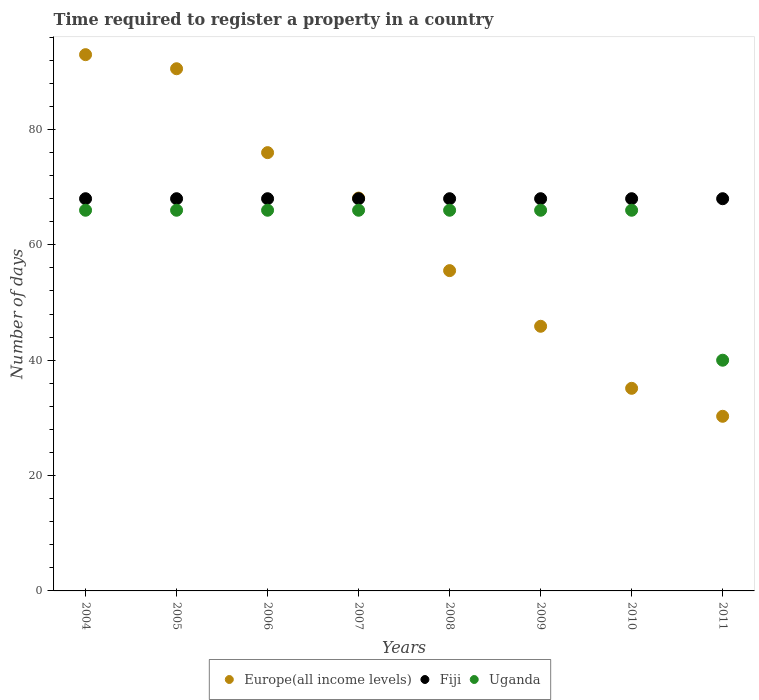Is the number of dotlines equal to the number of legend labels?
Give a very brief answer. Yes. What is the number of days required to register a property in Fiji in 2007?
Your response must be concise. 68. Across all years, what is the maximum number of days required to register a property in Europe(all income levels)?
Give a very brief answer. 92.98. Across all years, what is the minimum number of days required to register a property in Europe(all income levels)?
Your response must be concise. 30.28. In which year was the number of days required to register a property in Uganda maximum?
Your answer should be compact. 2004. In which year was the number of days required to register a property in Fiji minimum?
Your response must be concise. 2004. What is the total number of days required to register a property in Fiji in the graph?
Give a very brief answer. 544. What is the difference between the number of days required to register a property in Fiji in 2010 and the number of days required to register a property in Uganda in 2007?
Your response must be concise. 2. What is the average number of days required to register a property in Europe(all income levels) per year?
Your answer should be compact. 61.8. In the year 2010, what is the difference between the number of days required to register a property in Europe(all income levels) and number of days required to register a property in Fiji?
Your answer should be very brief. -32.87. In how many years, is the number of days required to register a property in Fiji greater than 44 days?
Offer a very short reply. 8. Is the difference between the number of days required to register a property in Europe(all income levels) in 2006 and 2010 greater than the difference between the number of days required to register a property in Fiji in 2006 and 2010?
Keep it short and to the point. Yes. What is the difference between the highest and the lowest number of days required to register a property in Uganda?
Offer a terse response. 26. Is the sum of the number of days required to register a property in Europe(all income levels) in 2006 and 2008 greater than the maximum number of days required to register a property in Fiji across all years?
Offer a very short reply. Yes. Is the number of days required to register a property in Uganda strictly less than the number of days required to register a property in Fiji over the years?
Make the answer very short. Yes. What is the difference between two consecutive major ticks on the Y-axis?
Provide a succinct answer. 20. Are the values on the major ticks of Y-axis written in scientific E-notation?
Offer a terse response. No. Does the graph contain any zero values?
Your response must be concise. No. Does the graph contain grids?
Ensure brevity in your answer.  No. Where does the legend appear in the graph?
Ensure brevity in your answer.  Bottom center. How are the legend labels stacked?
Your response must be concise. Horizontal. What is the title of the graph?
Your answer should be very brief. Time required to register a property in a country. What is the label or title of the Y-axis?
Ensure brevity in your answer.  Number of days. What is the Number of days in Europe(all income levels) in 2004?
Your answer should be compact. 92.98. What is the Number of days in Fiji in 2004?
Keep it short and to the point. 68. What is the Number of days of Uganda in 2004?
Provide a short and direct response. 66. What is the Number of days of Europe(all income levels) in 2005?
Offer a terse response. 90.53. What is the Number of days of Fiji in 2005?
Your response must be concise. 68. What is the Number of days of Uganda in 2005?
Offer a terse response. 66. What is the Number of days of Europe(all income levels) in 2006?
Your response must be concise. 75.99. What is the Number of days of Fiji in 2006?
Keep it short and to the point. 68. What is the Number of days in Europe(all income levels) in 2007?
Make the answer very short. 68.11. What is the Number of days of Uganda in 2007?
Your response must be concise. 66. What is the Number of days of Europe(all income levels) in 2008?
Provide a short and direct response. 55.53. What is the Number of days of Fiji in 2008?
Provide a succinct answer. 68. What is the Number of days in Uganda in 2008?
Provide a short and direct response. 66. What is the Number of days in Europe(all income levels) in 2009?
Ensure brevity in your answer.  45.88. What is the Number of days in Europe(all income levels) in 2010?
Give a very brief answer. 35.13. What is the Number of days in Europe(all income levels) in 2011?
Your response must be concise. 30.28. Across all years, what is the maximum Number of days of Europe(all income levels)?
Ensure brevity in your answer.  92.98. Across all years, what is the maximum Number of days of Fiji?
Give a very brief answer. 68. Across all years, what is the minimum Number of days in Europe(all income levels)?
Offer a terse response. 30.28. Across all years, what is the minimum Number of days in Uganda?
Your response must be concise. 40. What is the total Number of days of Europe(all income levels) in the graph?
Make the answer very short. 494.43. What is the total Number of days in Fiji in the graph?
Offer a terse response. 544. What is the total Number of days in Uganda in the graph?
Your response must be concise. 502. What is the difference between the Number of days of Europe(all income levels) in 2004 and that in 2005?
Your answer should be compact. 2.44. What is the difference between the Number of days of Europe(all income levels) in 2004 and that in 2006?
Provide a short and direct response. 16.99. What is the difference between the Number of days in Fiji in 2004 and that in 2006?
Keep it short and to the point. 0. What is the difference between the Number of days in Uganda in 2004 and that in 2006?
Your answer should be compact. 0. What is the difference between the Number of days of Europe(all income levels) in 2004 and that in 2007?
Ensure brevity in your answer.  24.87. What is the difference between the Number of days in Europe(all income levels) in 2004 and that in 2008?
Your answer should be very brief. 37.44. What is the difference between the Number of days in Fiji in 2004 and that in 2008?
Give a very brief answer. 0. What is the difference between the Number of days in Uganda in 2004 and that in 2008?
Offer a terse response. 0. What is the difference between the Number of days in Europe(all income levels) in 2004 and that in 2009?
Your response must be concise. 47.09. What is the difference between the Number of days of Uganda in 2004 and that in 2009?
Ensure brevity in your answer.  0. What is the difference between the Number of days of Europe(all income levels) in 2004 and that in 2010?
Offer a terse response. 57.85. What is the difference between the Number of days of Fiji in 2004 and that in 2010?
Your answer should be very brief. 0. What is the difference between the Number of days in Europe(all income levels) in 2004 and that in 2011?
Your response must be concise. 62.7. What is the difference between the Number of days of Fiji in 2004 and that in 2011?
Give a very brief answer. 0. What is the difference between the Number of days of Uganda in 2004 and that in 2011?
Give a very brief answer. 26. What is the difference between the Number of days of Europe(all income levels) in 2005 and that in 2006?
Make the answer very short. 14.55. What is the difference between the Number of days in Uganda in 2005 and that in 2006?
Provide a short and direct response. 0. What is the difference between the Number of days in Europe(all income levels) in 2005 and that in 2007?
Keep it short and to the point. 22.42. What is the difference between the Number of days of Europe(all income levels) in 2005 and that in 2008?
Provide a succinct answer. 35. What is the difference between the Number of days in Fiji in 2005 and that in 2008?
Your answer should be compact. 0. What is the difference between the Number of days of Europe(all income levels) in 2005 and that in 2009?
Keep it short and to the point. 44.65. What is the difference between the Number of days in Fiji in 2005 and that in 2009?
Keep it short and to the point. 0. What is the difference between the Number of days in Europe(all income levels) in 2005 and that in 2010?
Make the answer very short. 55.41. What is the difference between the Number of days of Fiji in 2005 and that in 2010?
Give a very brief answer. 0. What is the difference between the Number of days of Europe(all income levels) in 2005 and that in 2011?
Your answer should be very brief. 60.26. What is the difference between the Number of days in Europe(all income levels) in 2006 and that in 2007?
Provide a succinct answer. 7.88. What is the difference between the Number of days of Fiji in 2006 and that in 2007?
Give a very brief answer. 0. What is the difference between the Number of days in Europe(all income levels) in 2006 and that in 2008?
Give a very brief answer. 20.46. What is the difference between the Number of days of Uganda in 2006 and that in 2008?
Keep it short and to the point. 0. What is the difference between the Number of days in Europe(all income levels) in 2006 and that in 2009?
Make the answer very short. 30.11. What is the difference between the Number of days in Europe(all income levels) in 2006 and that in 2010?
Keep it short and to the point. 40.86. What is the difference between the Number of days in Europe(all income levels) in 2006 and that in 2011?
Provide a succinct answer. 45.71. What is the difference between the Number of days in Europe(all income levels) in 2007 and that in 2008?
Make the answer very short. 12.58. What is the difference between the Number of days of Fiji in 2007 and that in 2008?
Provide a short and direct response. 0. What is the difference between the Number of days in Europe(all income levels) in 2007 and that in 2009?
Your response must be concise. 22.23. What is the difference between the Number of days in Fiji in 2007 and that in 2009?
Ensure brevity in your answer.  0. What is the difference between the Number of days in Uganda in 2007 and that in 2009?
Give a very brief answer. 0. What is the difference between the Number of days of Europe(all income levels) in 2007 and that in 2010?
Provide a short and direct response. 32.98. What is the difference between the Number of days of Uganda in 2007 and that in 2010?
Keep it short and to the point. 0. What is the difference between the Number of days of Europe(all income levels) in 2007 and that in 2011?
Ensure brevity in your answer.  37.83. What is the difference between the Number of days in Uganda in 2007 and that in 2011?
Give a very brief answer. 26. What is the difference between the Number of days of Europe(all income levels) in 2008 and that in 2009?
Provide a short and direct response. 9.65. What is the difference between the Number of days in Fiji in 2008 and that in 2009?
Provide a short and direct response. 0. What is the difference between the Number of days in Europe(all income levels) in 2008 and that in 2010?
Your response must be concise. 20.4. What is the difference between the Number of days of Europe(all income levels) in 2008 and that in 2011?
Make the answer very short. 25.26. What is the difference between the Number of days in Uganda in 2008 and that in 2011?
Provide a succinct answer. 26. What is the difference between the Number of days in Europe(all income levels) in 2009 and that in 2010?
Offer a very short reply. 10.76. What is the difference between the Number of days of Fiji in 2009 and that in 2010?
Keep it short and to the point. 0. What is the difference between the Number of days of Uganda in 2009 and that in 2010?
Make the answer very short. 0. What is the difference between the Number of days in Europe(all income levels) in 2009 and that in 2011?
Provide a succinct answer. 15.61. What is the difference between the Number of days of Europe(all income levels) in 2010 and that in 2011?
Your answer should be compact. 4.85. What is the difference between the Number of days of Europe(all income levels) in 2004 and the Number of days of Fiji in 2005?
Provide a succinct answer. 24.98. What is the difference between the Number of days of Europe(all income levels) in 2004 and the Number of days of Uganda in 2005?
Provide a short and direct response. 26.98. What is the difference between the Number of days of Europe(all income levels) in 2004 and the Number of days of Fiji in 2006?
Offer a terse response. 24.98. What is the difference between the Number of days of Europe(all income levels) in 2004 and the Number of days of Uganda in 2006?
Your answer should be compact. 26.98. What is the difference between the Number of days of Europe(all income levels) in 2004 and the Number of days of Fiji in 2007?
Your response must be concise. 24.98. What is the difference between the Number of days of Europe(all income levels) in 2004 and the Number of days of Uganda in 2007?
Your response must be concise. 26.98. What is the difference between the Number of days in Fiji in 2004 and the Number of days in Uganda in 2007?
Give a very brief answer. 2. What is the difference between the Number of days in Europe(all income levels) in 2004 and the Number of days in Fiji in 2008?
Provide a short and direct response. 24.98. What is the difference between the Number of days in Europe(all income levels) in 2004 and the Number of days in Uganda in 2008?
Ensure brevity in your answer.  26.98. What is the difference between the Number of days of Europe(all income levels) in 2004 and the Number of days of Fiji in 2009?
Offer a terse response. 24.98. What is the difference between the Number of days in Europe(all income levels) in 2004 and the Number of days in Uganda in 2009?
Provide a succinct answer. 26.98. What is the difference between the Number of days in Europe(all income levels) in 2004 and the Number of days in Fiji in 2010?
Ensure brevity in your answer.  24.98. What is the difference between the Number of days of Europe(all income levels) in 2004 and the Number of days of Uganda in 2010?
Provide a succinct answer. 26.98. What is the difference between the Number of days in Europe(all income levels) in 2004 and the Number of days in Fiji in 2011?
Your answer should be very brief. 24.98. What is the difference between the Number of days of Europe(all income levels) in 2004 and the Number of days of Uganda in 2011?
Offer a terse response. 52.98. What is the difference between the Number of days in Fiji in 2004 and the Number of days in Uganda in 2011?
Your answer should be very brief. 28. What is the difference between the Number of days in Europe(all income levels) in 2005 and the Number of days in Fiji in 2006?
Your response must be concise. 22.53. What is the difference between the Number of days in Europe(all income levels) in 2005 and the Number of days in Uganda in 2006?
Offer a terse response. 24.53. What is the difference between the Number of days in Europe(all income levels) in 2005 and the Number of days in Fiji in 2007?
Your answer should be compact. 22.53. What is the difference between the Number of days in Europe(all income levels) in 2005 and the Number of days in Uganda in 2007?
Give a very brief answer. 24.53. What is the difference between the Number of days in Europe(all income levels) in 2005 and the Number of days in Fiji in 2008?
Your response must be concise. 22.53. What is the difference between the Number of days in Europe(all income levels) in 2005 and the Number of days in Uganda in 2008?
Offer a very short reply. 24.53. What is the difference between the Number of days of Europe(all income levels) in 2005 and the Number of days of Fiji in 2009?
Your answer should be compact. 22.53. What is the difference between the Number of days of Europe(all income levels) in 2005 and the Number of days of Uganda in 2009?
Provide a succinct answer. 24.53. What is the difference between the Number of days in Fiji in 2005 and the Number of days in Uganda in 2009?
Ensure brevity in your answer.  2. What is the difference between the Number of days in Europe(all income levels) in 2005 and the Number of days in Fiji in 2010?
Keep it short and to the point. 22.53. What is the difference between the Number of days of Europe(all income levels) in 2005 and the Number of days of Uganda in 2010?
Provide a succinct answer. 24.53. What is the difference between the Number of days in Fiji in 2005 and the Number of days in Uganda in 2010?
Keep it short and to the point. 2. What is the difference between the Number of days of Europe(all income levels) in 2005 and the Number of days of Fiji in 2011?
Your answer should be compact. 22.53. What is the difference between the Number of days of Europe(all income levels) in 2005 and the Number of days of Uganda in 2011?
Your response must be concise. 50.53. What is the difference between the Number of days of Fiji in 2005 and the Number of days of Uganda in 2011?
Ensure brevity in your answer.  28. What is the difference between the Number of days of Europe(all income levels) in 2006 and the Number of days of Fiji in 2007?
Your answer should be very brief. 7.99. What is the difference between the Number of days of Europe(all income levels) in 2006 and the Number of days of Uganda in 2007?
Keep it short and to the point. 9.99. What is the difference between the Number of days of Europe(all income levels) in 2006 and the Number of days of Fiji in 2008?
Your answer should be very brief. 7.99. What is the difference between the Number of days of Europe(all income levels) in 2006 and the Number of days of Uganda in 2008?
Give a very brief answer. 9.99. What is the difference between the Number of days of Europe(all income levels) in 2006 and the Number of days of Fiji in 2009?
Offer a very short reply. 7.99. What is the difference between the Number of days of Europe(all income levels) in 2006 and the Number of days of Uganda in 2009?
Give a very brief answer. 9.99. What is the difference between the Number of days of Fiji in 2006 and the Number of days of Uganda in 2009?
Your answer should be very brief. 2. What is the difference between the Number of days of Europe(all income levels) in 2006 and the Number of days of Fiji in 2010?
Provide a short and direct response. 7.99. What is the difference between the Number of days of Europe(all income levels) in 2006 and the Number of days of Uganda in 2010?
Your answer should be very brief. 9.99. What is the difference between the Number of days of Europe(all income levels) in 2006 and the Number of days of Fiji in 2011?
Your answer should be very brief. 7.99. What is the difference between the Number of days of Europe(all income levels) in 2006 and the Number of days of Uganda in 2011?
Keep it short and to the point. 35.99. What is the difference between the Number of days in Europe(all income levels) in 2007 and the Number of days in Uganda in 2008?
Keep it short and to the point. 2.11. What is the difference between the Number of days in Fiji in 2007 and the Number of days in Uganda in 2008?
Your answer should be compact. 2. What is the difference between the Number of days in Europe(all income levels) in 2007 and the Number of days in Fiji in 2009?
Your response must be concise. 0.11. What is the difference between the Number of days of Europe(all income levels) in 2007 and the Number of days of Uganda in 2009?
Offer a terse response. 2.11. What is the difference between the Number of days of Europe(all income levels) in 2007 and the Number of days of Fiji in 2010?
Ensure brevity in your answer.  0.11. What is the difference between the Number of days in Europe(all income levels) in 2007 and the Number of days in Uganda in 2010?
Provide a short and direct response. 2.11. What is the difference between the Number of days of Europe(all income levels) in 2007 and the Number of days of Fiji in 2011?
Your answer should be compact. 0.11. What is the difference between the Number of days in Europe(all income levels) in 2007 and the Number of days in Uganda in 2011?
Your answer should be very brief. 28.11. What is the difference between the Number of days of Fiji in 2007 and the Number of days of Uganda in 2011?
Your response must be concise. 28. What is the difference between the Number of days in Europe(all income levels) in 2008 and the Number of days in Fiji in 2009?
Provide a succinct answer. -12.47. What is the difference between the Number of days in Europe(all income levels) in 2008 and the Number of days in Uganda in 2009?
Ensure brevity in your answer.  -10.47. What is the difference between the Number of days in Europe(all income levels) in 2008 and the Number of days in Fiji in 2010?
Give a very brief answer. -12.47. What is the difference between the Number of days in Europe(all income levels) in 2008 and the Number of days in Uganda in 2010?
Give a very brief answer. -10.47. What is the difference between the Number of days in Fiji in 2008 and the Number of days in Uganda in 2010?
Your response must be concise. 2. What is the difference between the Number of days of Europe(all income levels) in 2008 and the Number of days of Fiji in 2011?
Provide a succinct answer. -12.47. What is the difference between the Number of days in Europe(all income levels) in 2008 and the Number of days in Uganda in 2011?
Provide a short and direct response. 15.53. What is the difference between the Number of days of Fiji in 2008 and the Number of days of Uganda in 2011?
Your answer should be very brief. 28. What is the difference between the Number of days of Europe(all income levels) in 2009 and the Number of days of Fiji in 2010?
Offer a very short reply. -22.12. What is the difference between the Number of days in Europe(all income levels) in 2009 and the Number of days in Uganda in 2010?
Ensure brevity in your answer.  -20.12. What is the difference between the Number of days in Europe(all income levels) in 2009 and the Number of days in Fiji in 2011?
Your answer should be compact. -22.12. What is the difference between the Number of days of Europe(all income levels) in 2009 and the Number of days of Uganda in 2011?
Your response must be concise. 5.88. What is the difference between the Number of days of Fiji in 2009 and the Number of days of Uganda in 2011?
Keep it short and to the point. 28. What is the difference between the Number of days of Europe(all income levels) in 2010 and the Number of days of Fiji in 2011?
Ensure brevity in your answer.  -32.87. What is the difference between the Number of days of Europe(all income levels) in 2010 and the Number of days of Uganda in 2011?
Your answer should be compact. -4.87. What is the average Number of days in Europe(all income levels) per year?
Your response must be concise. 61.8. What is the average Number of days in Fiji per year?
Give a very brief answer. 68. What is the average Number of days in Uganda per year?
Offer a very short reply. 62.75. In the year 2004, what is the difference between the Number of days of Europe(all income levels) and Number of days of Fiji?
Give a very brief answer. 24.98. In the year 2004, what is the difference between the Number of days of Europe(all income levels) and Number of days of Uganda?
Provide a short and direct response. 26.98. In the year 2005, what is the difference between the Number of days of Europe(all income levels) and Number of days of Fiji?
Ensure brevity in your answer.  22.53. In the year 2005, what is the difference between the Number of days of Europe(all income levels) and Number of days of Uganda?
Provide a short and direct response. 24.53. In the year 2005, what is the difference between the Number of days of Fiji and Number of days of Uganda?
Your answer should be very brief. 2. In the year 2006, what is the difference between the Number of days of Europe(all income levels) and Number of days of Fiji?
Your answer should be compact. 7.99. In the year 2006, what is the difference between the Number of days of Europe(all income levels) and Number of days of Uganda?
Offer a very short reply. 9.99. In the year 2007, what is the difference between the Number of days of Europe(all income levels) and Number of days of Fiji?
Your answer should be very brief. 0.11. In the year 2007, what is the difference between the Number of days of Europe(all income levels) and Number of days of Uganda?
Ensure brevity in your answer.  2.11. In the year 2008, what is the difference between the Number of days in Europe(all income levels) and Number of days in Fiji?
Your answer should be very brief. -12.47. In the year 2008, what is the difference between the Number of days of Europe(all income levels) and Number of days of Uganda?
Your answer should be very brief. -10.47. In the year 2009, what is the difference between the Number of days of Europe(all income levels) and Number of days of Fiji?
Your answer should be compact. -22.12. In the year 2009, what is the difference between the Number of days in Europe(all income levels) and Number of days in Uganda?
Your answer should be compact. -20.12. In the year 2010, what is the difference between the Number of days of Europe(all income levels) and Number of days of Fiji?
Offer a very short reply. -32.87. In the year 2010, what is the difference between the Number of days of Europe(all income levels) and Number of days of Uganda?
Your response must be concise. -30.87. In the year 2010, what is the difference between the Number of days of Fiji and Number of days of Uganda?
Provide a short and direct response. 2. In the year 2011, what is the difference between the Number of days of Europe(all income levels) and Number of days of Fiji?
Provide a short and direct response. -37.72. In the year 2011, what is the difference between the Number of days in Europe(all income levels) and Number of days in Uganda?
Your answer should be compact. -9.72. What is the ratio of the Number of days in Europe(all income levels) in 2004 to that in 2005?
Provide a short and direct response. 1.03. What is the ratio of the Number of days of Europe(all income levels) in 2004 to that in 2006?
Give a very brief answer. 1.22. What is the ratio of the Number of days of Europe(all income levels) in 2004 to that in 2007?
Give a very brief answer. 1.37. What is the ratio of the Number of days in Uganda in 2004 to that in 2007?
Offer a very short reply. 1. What is the ratio of the Number of days of Europe(all income levels) in 2004 to that in 2008?
Give a very brief answer. 1.67. What is the ratio of the Number of days in Europe(all income levels) in 2004 to that in 2009?
Offer a very short reply. 2.03. What is the ratio of the Number of days of Europe(all income levels) in 2004 to that in 2010?
Your answer should be compact. 2.65. What is the ratio of the Number of days of Fiji in 2004 to that in 2010?
Keep it short and to the point. 1. What is the ratio of the Number of days of Europe(all income levels) in 2004 to that in 2011?
Give a very brief answer. 3.07. What is the ratio of the Number of days in Uganda in 2004 to that in 2011?
Provide a short and direct response. 1.65. What is the ratio of the Number of days of Europe(all income levels) in 2005 to that in 2006?
Your answer should be compact. 1.19. What is the ratio of the Number of days of Fiji in 2005 to that in 2006?
Make the answer very short. 1. What is the ratio of the Number of days of Europe(all income levels) in 2005 to that in 2007?
Make the answer very short. 1.33. What is the ratio of the Number of days in Uganda in 2005 to that in 2007?
Your response must be concise. 1. What is the ratio of the Number of days in Europe(all income levels) in 2005 to that in 2008?
Make the answer very short. 1.63. What is the ratio of the Number of days of Europe(all income levels) in 2005 to that in 2009?
Keep it short and to the point. 1.97. What is the ratio of the Number of days in Fiji in 2005 to that in 2009?
Provide a short and direct response. 1. What is the ratio of the Number of days in Europe(all income levels) in 2005 to that in 2010?
Your answer should be compact. 2.58. What is the ratio of the Number of days of Europe(all income levels) in 2005 to that in 2011?
Provide a short and direct response. 2.99. What is the ratio of the Number of days of Uganda in 2005 to that in 2011?
Make the answer very short. 1.65. What is the ratio of the Number of days in Europe(all income levels) in 2006 to that in 2007?
Your response must be concise. 1.12. What is the ratio of the Number of days of Fiji in 2006 to that in 2007?
Your response must be concise. 1. What is the ratio of the Number of days in Europe(all income levels) in 2006 to that in 2008?
Give a very brief answer. 1.37. What is the ratio of the Number of days of Europe(all income levels) in 2006 to that in 2009?
Provide a short and direct response. 1.66. What is the ratio of the Number of days in Uganda in 2006 to that in 2009?
Provide a succinct answer. 1. What is the ratio of the Number of days in Europe(all income levels) in 2006 to that in 2010?
Offer a terse response. 2.16. What is the ratio of the Number of days of Fiji in 2006 to that in 2010?
Your answer should be very brief. 1. What is the ratio of the Number of days in Uganda in 2006 to that in 2010?
Offer a terse response. 1. What is the ratio of the Number of days in Europe(all income levels) in 2006 to that in 2011?
Make the answer very short. 2.51. What is the ratio of the Number of days in Uganda in 2006 to that in 2011?
Ensure brevity in your answer.  1.65. What is the ratio of the Number of days of Europe(all income levels) in 2007 to that in 2008?
Give a very brief answer. 1.23. What is the ratio of the Number of days in Europe(all income levels) in 2007 to that in 2009?
Your response must be concise. 1.48. What is the ratio of the Number of days of Fiji in 2007 to that in 2009?
Provide a short and direct response. 1. What is the ratio of the Number of days of Uganda in 2007 to that in 2009?
Make the answer very short. 1. What is the ratio of the Number of days in Europe(all income levels) in 2007 to that in 2010?
Your answer should be compact. 1.94. What is the ratio of the Number of days of Uganda in 2007 to that in 2010?
Your response must be concise. 1. What is the ratio of the Number of days in Europe(all income levels) in 2007 to that in 2011?
Offer a very short reply. 2.25. What is the ratio of the Number of days in Fiji in 2007 to that in 2011?
Make the answer very short. 1. What is the ratio of the Number of days in Uganda in 2007 to that in 2011?
Give a very brief answer. 1.65. What is the ratio of the Number of days in Europe(all income levels) in 2008 to that in 2009?
Provide a short and direct response. 1.21. What is the ratio of the Number of days of Fiji in 2008 to that in 2009?
Keep it short and to the point. 1. What is the ratio of the Number of days of Europe(all income levels) in 2008 to that in 2010?
Provide a short and direct response. 1.58. What is the ratio of the Number of days in Fiji in 2008 to that in 2010?
Make the answer very short. 1. What is the ratio of the Number of days of Uganda in 2008 to that in 2010?
Your response must be concise. 1. What is the ratio of the Number of days in Europe(all income levels) in 2008 to that in 2011?
Give a very brief answer. 1.83. What is the ratio of the Number of days in Fiji in 2008 to that in 2011?
Ensure brevity in your answer.  1. What is the ratio of the Number of days of Uganda in 2008 to that in 2011?
Your response must be concise. 1.65. What is the ratio of the Number of days of Europe(all income levels) in 2009 to that in 2010?
Keep it short and to the point. 1.31. What is the ratio of the Number of days of Europe(all income levels) in 2009 to that in 2011?
Make the answer very short. 1.52. What is the ratio of the Number of days in Fiji in 2009 to that in 2011?
Offer a very short reply. 1. What is the ratio of the Number of days in Uganda in 2009 to that in 2011?
Your response must be concise. 1.65. What is the ratio of the Number of days of Europe(all income levels) in 2010 to that in 2011?
Ensure brevity in your answer.  1.16. What is the ratio of the Number of days in Fiji in 2010 to that in 2011?
Give a very brief answer. 1. What is the ratio of the Number of days of Uganda in 2010 to that in 2011?
Give a very brief answer. 1.65. What is the difference between the highest and the second highest Number of days of Europe(all income levels)?
Provide a succinct answer. 2.44. What is the difference between the highest and the second highest Number of days in Uganda?
Keep it short and to the point. 0. What is the difference between the highest and the lowest Number of days in Europe(all income levels)?
Provide a succinct answer. 62.7. What is the difference between the highest and the lowest Number of days in Fiji?
Ensure brevity in your answer.  0. What is the difference between the highest and the lowest Number of days of Uganda?
Your answer should be compact. 26. 